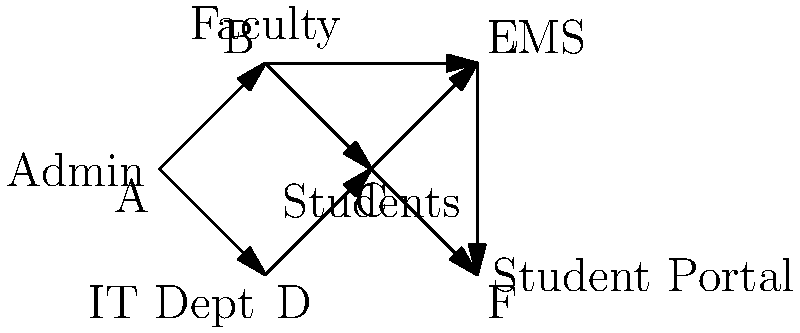In the directed graph representing a university's digital ecosystem, what is the minimum number of steps required for information to flow from the Administration (A) to the Student Portal (F)? To find the minimum number of steps for information to flow from Administration (A) to the Student Portal (F), we need to identify the shortest path between these two nodes. Let's analyze the possible paths:

1. Path 1: A → B → C → F
   - A to B: 1 step
   - B to C: 1 step
   - C to F: 1 step
   Total: 3 steps

2. Path 2: A → B → E → F
   - A to B: 1 step
   - B to E: 1 step
   - E to F: 1 step
   Total: 3 steps

3. Path 3: A → D → C → F
   - A to D: 1 step
   - D to C: 1 step
   - C to F: 1 step
   Total: 3 steps

4. Path 4: A → D → C → E → F
   - A to D: 1 step
   - D to C: 1 step
   - C to E: 1 step
   - E to F: 1 step
   Total: 4 steps

The minimum number of steps is 3, which can be achieved through either Path 1, Path 2, or Path 3.
Answer: 3 steps 